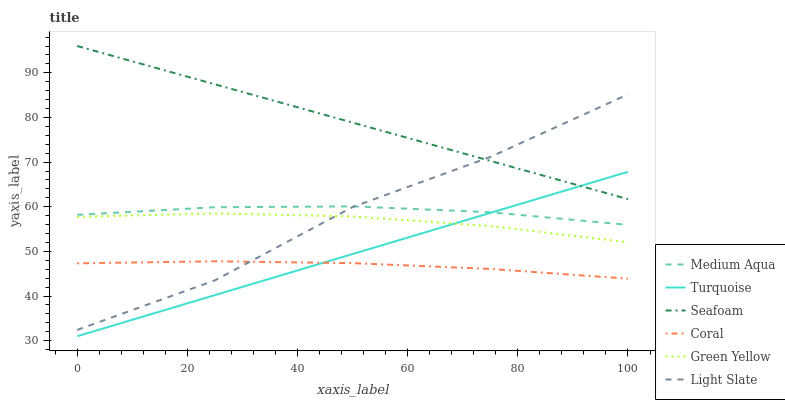Does Coral have the minimum area under the curve?
Answer yes or no. Yes. Does Seafoam have the maximum area under the curve?
Answer yes or no. Yes. Does Light Slate have the minimum area under the curve?
Answer yes or no. No. Does Light Slate have the maximum area under the curve?
Answer yes or no. No. Is Seafoam the smoothest?
Answer yes or no. Yes. Is Light Slate the roughest?
Answer yes or no. Yes. Is Coral the smoothest?
Answer yes or no. No. Is Coral the roughest?
Answer yes or no. No. Does Turquoise have the lowest value?
Answer yes or no. Yes. Does Light Slate have the lowest value?
Answer yes or no. No. Does Seafoam have the highest value?
Answer yes or no. Yes. Does Light Slate have the highest value?
Answer yes or no. No. Is Medium Aqua less than Seafoam?
Answer yes or no. Yes. Is Green Yellow greater than Coral?
Answer yes or no. Yes. Does Light Slate intersect Coral?
Answer yes or no. Yes. Is Light Slate less than Coral?
Answer yes or no. No. Is Light Slate greater than Coral?
Answer yes or no. No. Does Medium Aqua intersect Seafoam?
Answer yes or no. No. 